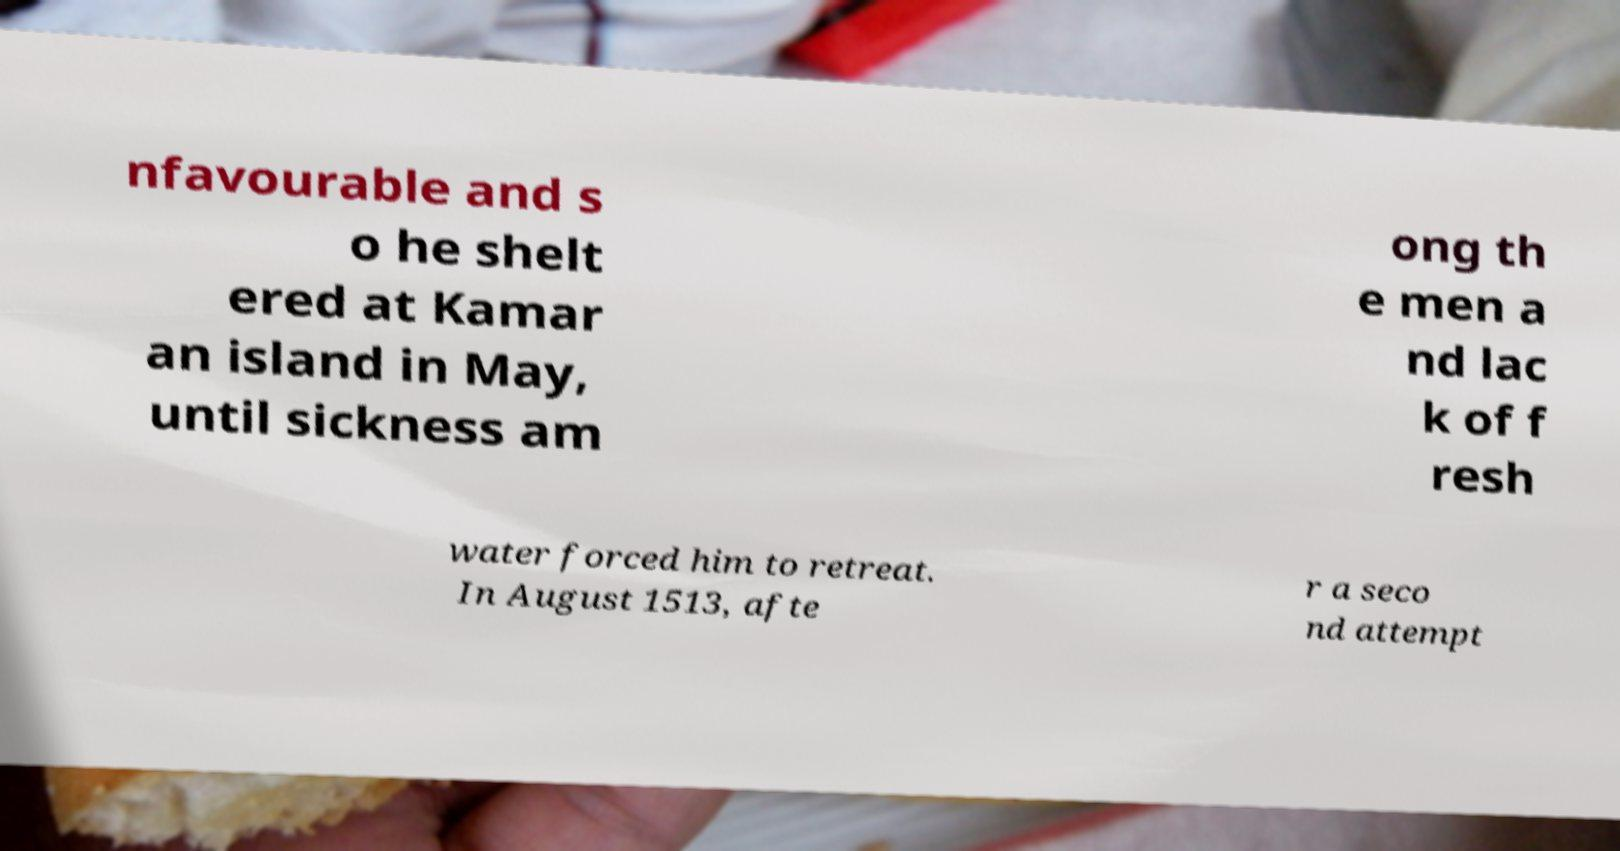I need the written content from this picture converted into text. Can you do that? nfavourable and s o he shelt ered at Kamar an island in May, until sickness am ong th e men a nd lac k of f resh water forced him to retreat. In August 1513, afte r a seco nd attempt 